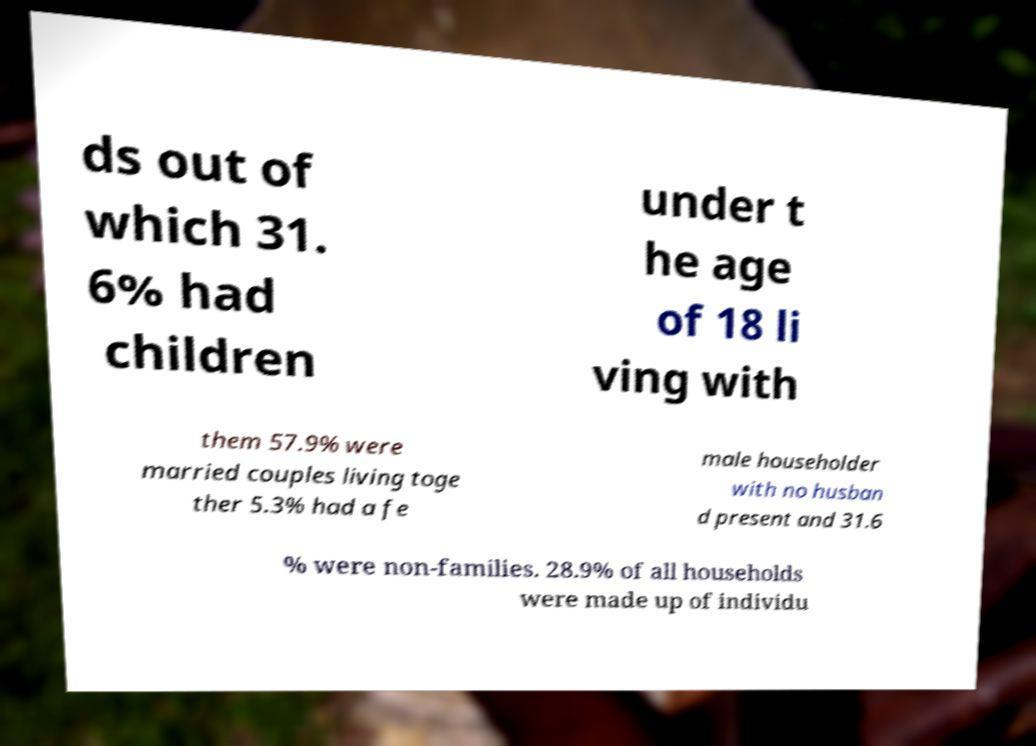Please identify and transcribe the text found in this image. ds out of which 31. 6% had children under t he age of 18 li ving with them 57.9% were married couples living toge ther 5.3% had a fe male householder with no husban d present and 31.6 % were non-families. 28.9% of all households were made up of individu 